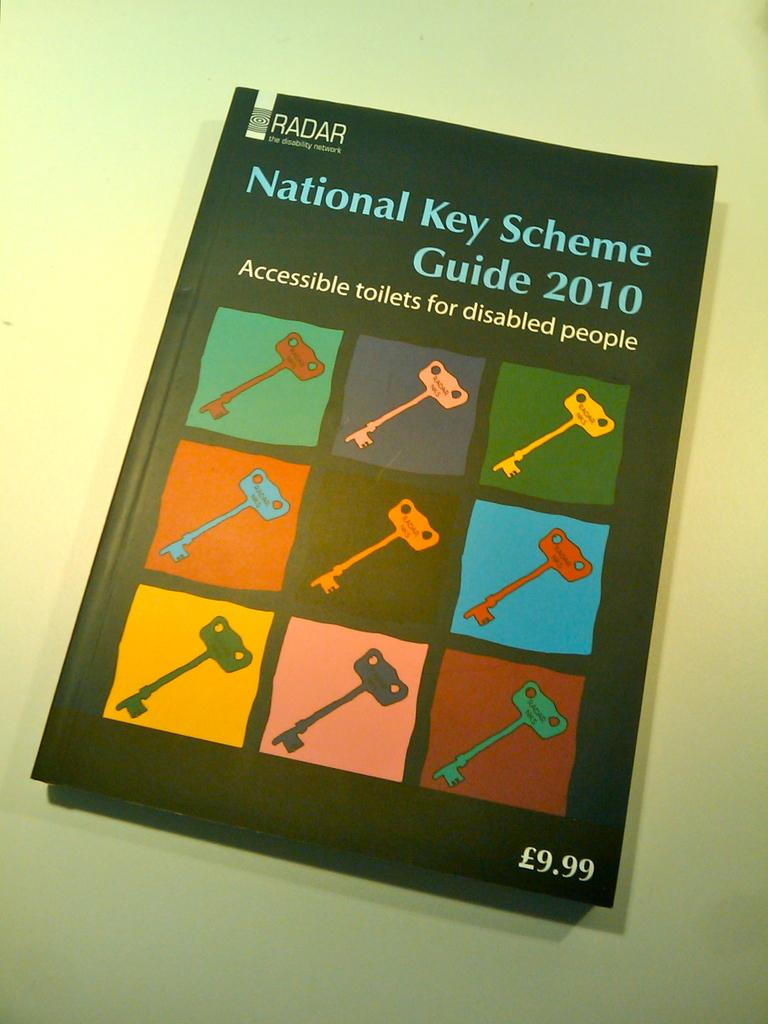<image>
Create a compact narrative representing the image presented. a book entitled National Key Scheme Guide 2010 for disabled people 